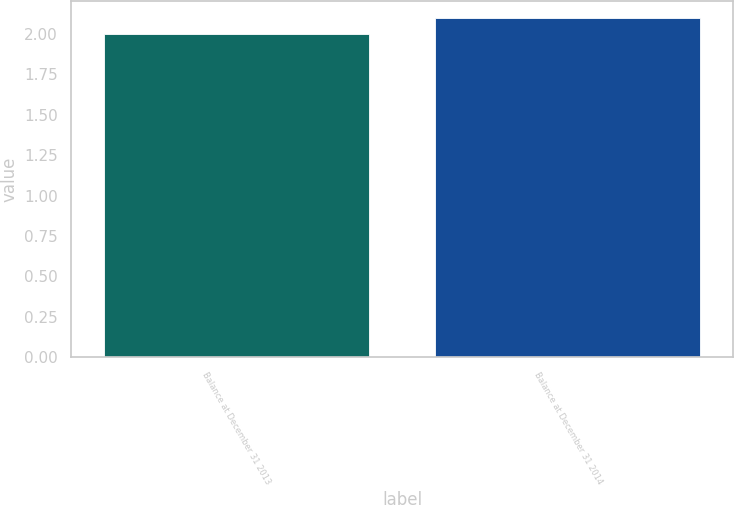<chart> <loc_0><loc_0><loc_500><loc_500><bar_chart><fcel>Balance at December 31 2013<fcel>Balance at December 31 2014<nl><fcel>2<fcel>2.1<nl></chart> 